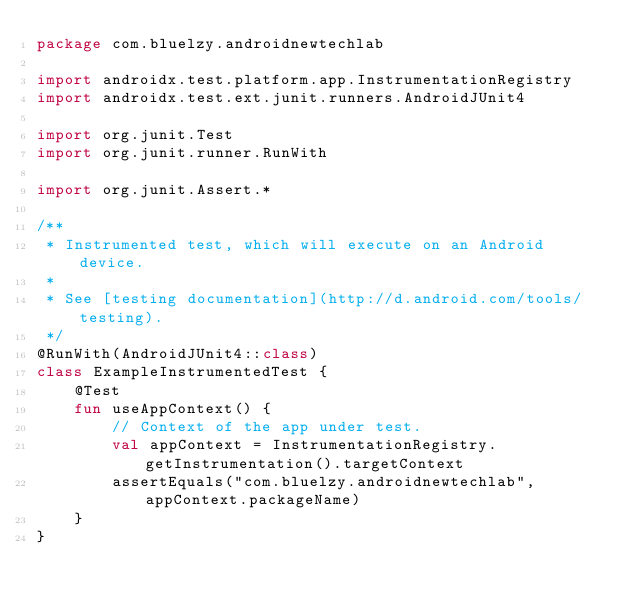<code> <loc_0><loc_0><loc_500><loc_500><_Kotlin_>package com.bluelzy.androidnewtechlab

import androidx.test.platform.app.InstrumentationRegistry
import androidx.test.ext.junit.runners.AndroidJUnit4

import org.junit.Test
import org.junit.runner.RunWith

import org.junit.Assert.*

/**
 * Instrumented test, which will execute on an Android device.
 *
 * See [testing documentation](http://d.android.com/tools/testing).
 */
@RunWith(AndroidJUnit4::class)
class ExampleInstrumentedTest {
    @Test
    fun useAppContext() {
        // Context of the app under test.
        val appContext = InstrumentationRegistry.getInstrumentation().targetContext
        assertEquals("com.bluelzy.androidnewtechlab", appContext.packageName)
    }
}</code> 